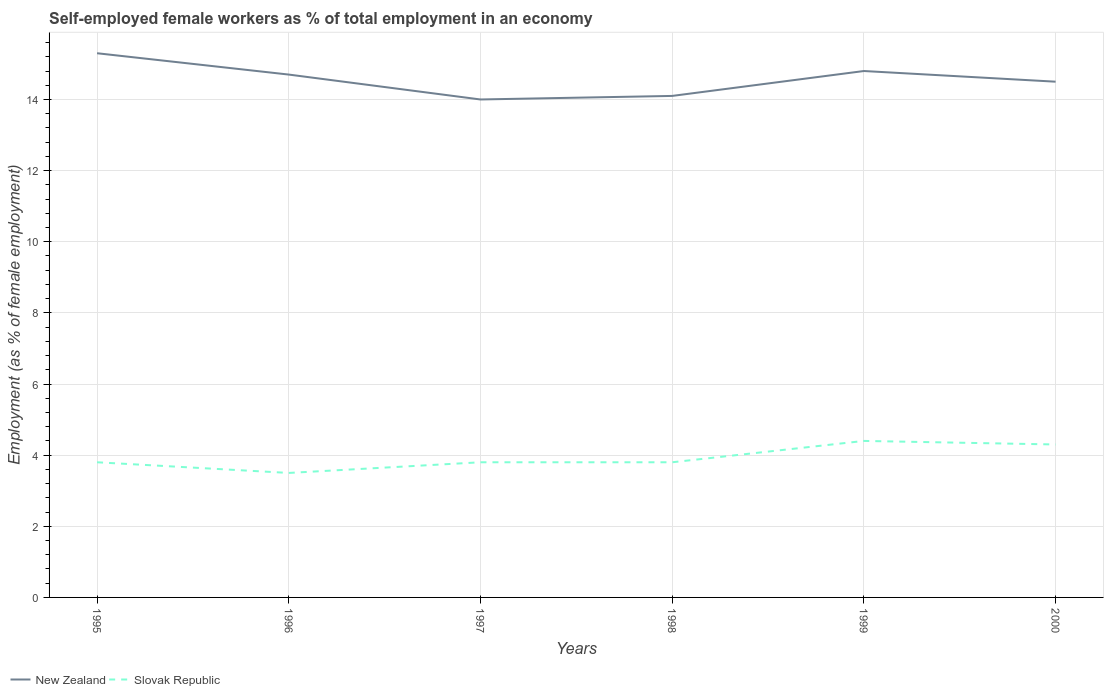How many different coloured lines are there?
Keep it short and to the point. 2. In which year was the percentage of self-employed female workers in New Zealand maximum?
Keep it short and to the point. 1997. What is the total percentage of self-employed female workers in Slovak Republic in the graph?
Make the answer very short. 0. What is the difference between the highest and the second highest percentage of self-employed female workers in Slovak Republic?
Your response must be concise. 0.9. Is the percentage of self-employed female workers in New Zealand strictly greater than the percentage of self-employed female workers in Slovak Republic over the years?
Give a very brief answer. No. How many lines are there?
Your answer should be very brief. 2. How many years are there in the graph?
Your answer should be compact. 6. What is the difference between two consecutive major ticks on the Y-axis?
Provide a short and direct response. 2. Are the values on the major ticks of Y-axis written in scientific E-notation?
Keep it short and to the point. No. How many legend labels are there?
Give a very brief answer. 2. What is the title of the graph?
Your answer should be compact. Self-employed female workers as % of total employment in an economy. Does "Colombia" appear as one of the legend labels in the graph?
Make the answer very short. No. What is the label or title of the Y-axis?
Ensure brevity in your answer.  Employment (as % of female employment). What is the Employment (as % of female employment) in New Zealand in 1995?
Provide a short and direct response. 15.3. What is the Employment (as % of female employment) in Slovak Republic in 1995?
Offer a very short reply. 3.8. What is the Employment (as % of female employment) in New Zealand in 1996?
Provide a short and direct response. 14.7. What is the Employment (as % of female employment) in Slovak Republic in 1996?
Ensure brevity in your answer.  3.5. What is the Employment (as % of female employment) of New Zealand in 1997?
Your answer should be compact. 14. What is the Employment (as % of female employment) of Slovak Republic in 1997?
Your response must be concise. 3.8. What is the Employment (as % of female employment) in New Zealand in 1998?
Your answer should be very brief. 14.1. What is the Employment (as % of female employment) in Slovak Republic in 1998?
Provide a succinct answer. 3.8. What is the Employment (as % of female employment) of New Zealand in 1999?
Keep it short and to the point. 14.8. What is the Employment (as % of female employment) of Slovak Republic in 1999?
Offer a very short reply. 4.4. What is the Employment (as % of female employment) in New Zealand in 2000?
Make the answer very short. 14.5. What is the Employment (as % of female employment) in Slovak Republic in 2000?
Ensure brevity in your answer.  4.3. Across all years, what is the maximum Employment (as % of female employment) in New Zealand?
Ensure brevity in your answer.  15.3. Across all years, what is the maximum Employment (as % of female employment) in Slovak Republic?
Your answer should be very brief. 4.4. What is the total Employment (as % of female employment) of New Zealand in the graph?
Keep it short and to the point. 87.4. What is the total Employment (as % of female employment) in Slovak Republic in the graph?
Ensure brevity in your answer.  23.6. What is the difference between the Employment (as % of female employment) of Slovak Republic in 1995 and that in 1996?
Your answer should be compact. 0.3. What is the difference between the Employment (as % of female employment) in New Zealand in 1995 and that in 1998?
Provide a short and direct response. 1.2. What is the difference between the Employment (as % of female employment) of New Zealand in 1995 and that in 1999?
Your answer should be compact. 0.5. What is the difference between the Employment (as % of female employment) in Slovak Republic in 1995 and that in 1999?
Keep it short and to the point. -0.6. What is the difference between the Employment (as % of female employment) in Slovak Republic in 1996 and that in 1997?
Ensure brevity in your answer.  -0.3. What is the difference between the Employment (as % of female employment) in New Zealand in 1996 and that in 1998?
Your answer should be compact. 0.6. What is the difference between the Employment (as % of female employment) in Slovak Republic in 1996 and that in 1999?
Offer a very short reply. -0.9. What is the difference between the Employment (as % of female employment) in New Zealand in 1997 and that in 1998?
Make the answer very short. -0.1. What is the difference between the Employment (as % of female employment) in New Zealand in 1997 and that in 1999?
Ensure brevity in your answer.  -0.8. What is the difference between the Employment (as % of female employment) in New Zealand in 1998 and that in 1999?
Provide a succinct answer. -0.7. What is the difference between the Employment (as % of female employment) in New Zealand in 1999 and that in 2000?
Your response must be concise. 0.3. What is the difference between the Employment (as % of female employment) of Slovak Republic in 1999 and that in 2000?
Give a very brief answer. 0.1. What is the difference between the Employment (as % of female employment) in New Zealand in 1995 and the Employment (as % of female employment) in Slovak Republic in 1996?
Make the answer very short. 11.8. What is the difference between the Employment (as % of female employment) in New Zealand in 1995 and the Employment (as % of female employment) in Slovak Republic in 1998?
Offer a very short reply. 11.5. What is the difference between the Employment (as % of female employment) in New Zealand in 1995 and the Employment (as % of female employment) in Slovak Republic in 1999?
Offer a very short reply. 10.9. What is the difference between the Employment (as % of female employment) of New Zealand in 1996 and the Employment (as % of female employment) of Slovak Republic in 1997?
Offer a very short reply. 10.9. What is the difference between the Employment (as % of female employment) of New Zealand in 1997 and the Employment (as % of female employment) of Slovak Republic in 1998?
Your answer should be compact. 10.2. What is the difference between the Employment (as % of female employment) of New Zealand in 1997 and the Employment (as % of female employment) of Slovak Republic in 1999?
Ensure brevity in your answer.  9.6. What is the difference between the Employment (as % of female employment) in New Zealand in 1998 and the Employment (as % of female employment) in Slovak Republic in 1999?
Keep it short and to the point. 9.7. What is the difference between the Employment (as % of female employment) of New Zealand in 1998 and the Employment (as % of female employment) of Slovak Republic in 2000?
Your response must be concise. 9.8. What is the average Employment (as % of female employment) in New Zealand per year?
Offer a terse response. 14.57. What is the average Employment (as % of female employment) in Slovak Republic per year?
Provide a short and direct response. 3.93. In the year 1998, what is the difference between the Employment (as % of female employment) in New Zealand and Employment (as % of female employment) in Slovak Republic?
Your answer should be very brief. 10.3. In the year 1999, what is the difference between the Employment (as % of female employment) of New Zealand and Employment (as % of female employment) of Slovak Republic?
Give a very brief answer. 10.4. In the year 2000, what is the difference between the Employment (as % of female employment) of New Zealand and Employment (as % of female employment) of Slovak Republic?
Your answer should be very brief. 10.2. What is the ratio of the Employment (as % of female employment) of New Zealand in 1995 to that in 1996?
Your response must be concise. 1.04. What is the ratio of the Employment (as % of female employment) of Slovak Republic in 1995 to that in 1996?
Offer a terse response. 1.09. What is the ratio of the Employment (as % of female employment) in New Zealand in 1995 to that in 1997?
Ensure brevity in your answer.  1.09. What is the ratio of the Employment (as % of female employment) of New Zealand in 1995 to that in 1998?
Make the answer very short. 1.09. What is the ratio of the Employment (as % of female employment) of New Zealand in 1995 to that in 1999?
Offer a terse response. 1.03. What is the ratio of the Employment (as % of female employment) of Slovak Republic in 1995 to that in 1999?
Your answer should be compact. 0.86. What is the ratio of the Employment (as % of female employment) in New Zealand in 1995 to that in 2000?
Your response must be concise. 1.06. What is the ratio of the Employment (as % of female employment) in Slovak Republic in 1995 to that in 2000?
Make the answer very short. 0.88. What is the ratio of the Employment (as % of female employment) in New Zealand in 1996 to that in 1997?
Provide a short and direct response. 1.05. What is the ratio of the Employment (as % of female employment) in Slovak Republic in 1996 to that in 1997?
Give a very brief answer. 0.92. What is the ratio of the Employment (as % of female employment) in New Zealand in 1996 to that in 1998?
Your answer should be compact. 1.04. What is the ratio of the Employment (as % of female employment) of Slovak Republic in 1996 to that in 1998?
Your answer should be compact. 0.92. What is the ratio of the Employment (as % of female employment) of Slovak Republic in 1996 to that in 1999?
Your answer should be compact. 0.8. What is the ratio of the Employment (as % of female employment) of New Zealand in 1996 to that in 2000?
Your response must be concise. 1.01. What is the ratio of the Employment (as % of female employment) in Slovak Republic in 1996 to that in 2000?
Your response must be concise. 0.81. What is the ratio of the Employment (as % of female employment) of New Zealand in 1997 to that in 1999?
Keep it short and to the point. 0.95. What is the ratio of the Employment (as % of female employment) of Slovak Republic in 1997 to that in 1999?
Offer a terse response. 0.86. What is the ratio of the Employment (as % of female employment) of New Zealand in 1997 to that in 2000?
Your answer should be very brief. 0.97. What is the ratio of the Employment (as % of female employment) of Slovak Republic in 1997 to that in 2000?
Ensure brevity in your answer.  0.88. What is the ratio of the Employment (as % of female employment) in New Zealand in 1998 to that in 1999?
Keep it short and to the point. 0.95. What is the ratio of the Employment (as % of female employment) of Slovak Republic in 1998 to that in 1999?
Provide a succinct answer. 0.86. What is the ratio of the Employment (as % of female employment) in New Zealand in 1998 to that in 2000?
Offer a terse response. 0.97. What is the ratio of the Employment (as % of female employment) of Slovak Republic in 1998 to that in 2000?
Give a very brief answer. 0.88. What is the ratio of the Employment (as % of female employment) of New Zealand in 1999 to that in 2000?
Keep it short and to the point. 1.02. What is the ratio of the Employment (as % of female employment) in Slovak Republic in 1999 to that in 2000?
Ensure brevity in your answer.  1.02. What is the difference between the highest and the second highest Employment (as % of female employment) in New Zealand?
Provide a succinct answer. 0.5. What is the difference between the highest and the second highest Employment (as % of female employment) in Slovak Republic?
Provide a succinct answer. 0.1. What is the difference between the highest and the lowest Employment (as % of female employment) of New Zealand?
Provide a short and direct response. 1.3. What is the difference between the highest and the lowest Employment (as % of female employment) in Slovak Republic?
Keep it short and to the point. 0.9. 